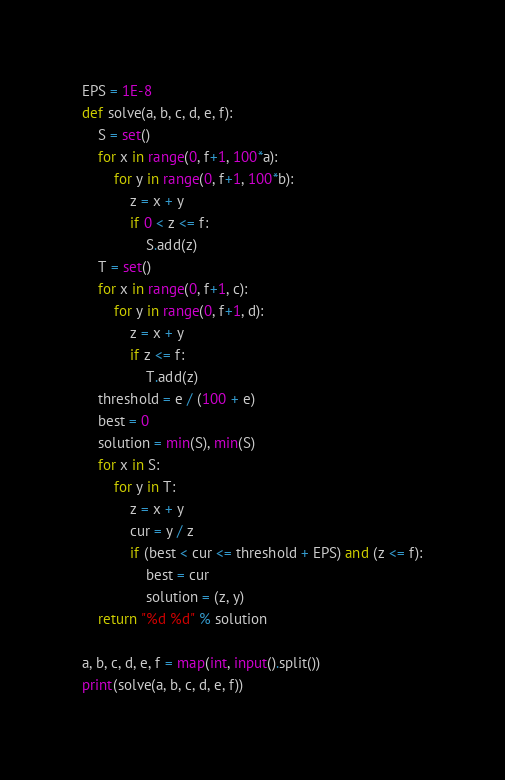<code> <loc_0><loc_0><loc_500><loc_500><_Python_>EPS = 1E-8
def solve(a, b, c, d, e, f):
    S = set()
    for x in range(0, f+1, 100*a):
        for y in range(0, f+1, 100*b):
            z = x + y
            if 0 < z <= f:
                S.add(z)
    T = set()
    for x in range(0, f+1, c):
        for y in range(0, f+1, d):
            z = x + y
            if z <= f:
                T.add(z)
    threshold = e / (100 + e)
    best = 0
    solution = min(S), min(S)
    for x in S:
        for y in T:
            z = x + y
            cur = y / z
            if (best < cur <= threshold + EPS) and (z <= f):
                best = cur 
                solution = (z, y)
    return "%d %d" % solution

a, b, c, d, e, f = map(int, input().split())
print(solve(a, b, c, d, e, f))</code> 